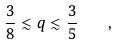<formula> <loc_0><loc_0><loc_500><loc_500>\frac { 3 } { 8 } \lesssim q \lesssim \frac { 3 } { 5 } \quad ,</formula> 